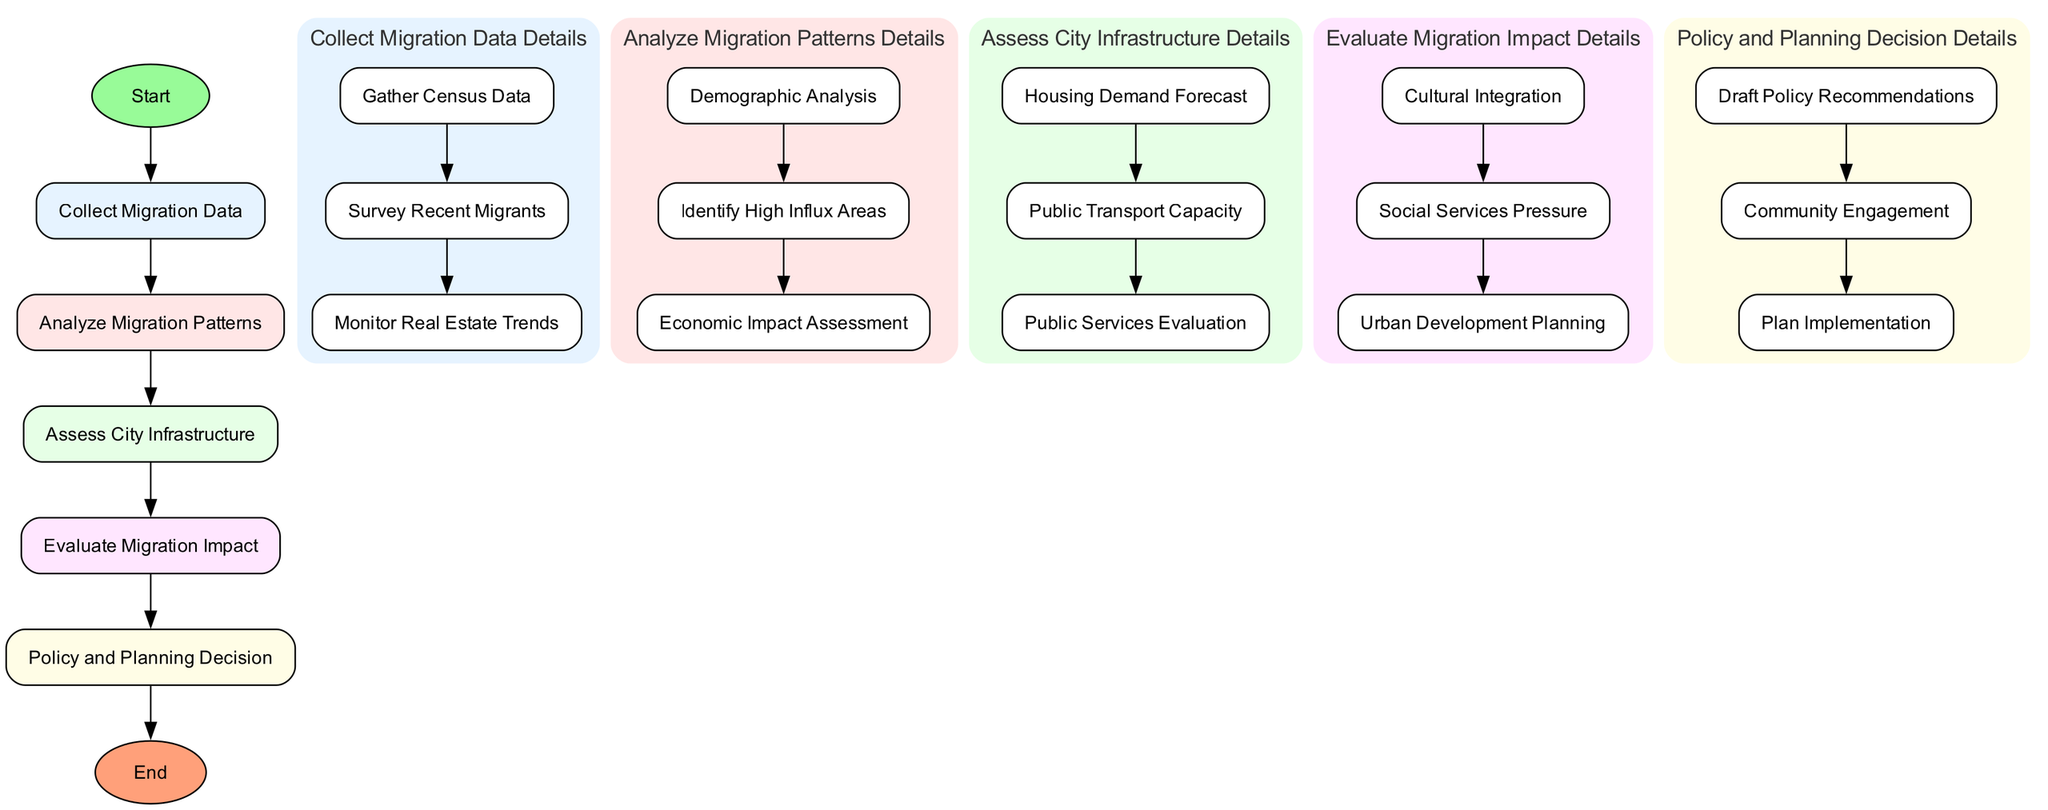What is the first process in the flowchart? The flowchart starts with the 'dataCollection' process, which follows the initial 'Start' node.
Answer: dataCollection How many main processes are there in total? The flowchart lists five main processes: dataCollection, dataAnalysis, infrastructureAssessment, migrationImpact, and decisionMaking. Counting these gives a total of five.
Answer: 5 What is the last subprocess under the 'migrationImpact'? The last subprocess listed under 'migrationImpact' is 'Urban Development Planning'.
Answer: Urban Development Planning What is the last process before reaching the 'End' node? The last main process before the 'End' node is 'decisionMaking', which is reached after completing all previous processes.
Answer: decisionMaking Which subprocess deals with predicting new housing needs? The subprocess that focuses on predicting new housing needs is 'Housing Demand Forecast', which is under 'infrastructureAssessment'.
Answer: Housing Demand Forecast What relationships exist between 'dataAnalysis' and 'infrastructureAssessment'? 'dataAnalysis' follows 'dataCollection' and precedes 'infrastructureAssessment'; this indicates a sequential relationship where data is analyzed before assessing infrastructure needs.
Answer: Sequential relationship How many subprocesses are there in the 'dataCollection' phase? The 'dataCollection' phase consists of three subprocesses: 'Gather Census Data', 'Survey Recent Migrants', and 'Monitor Real Estate Trends', leading to a total of three.
Answer: 3 What type of evaluation is performed on schools and healthcare services? The evaluation performed on schools and healthcare services is referred to as 'Public Services Evaluation', which is a subprocess under the 'infrastructureAssessment' phase.
Answer: Public Services Evaluation What is the function of 'Community Engagement' in the decision-making process? 'Community Engagement' serves to involve and obtain feedback from community stakeholders as part of the 'Policy and Planning Decision' process, ensuring their needs and perspectives are considered.
Answer: Engage with community stakeholders 